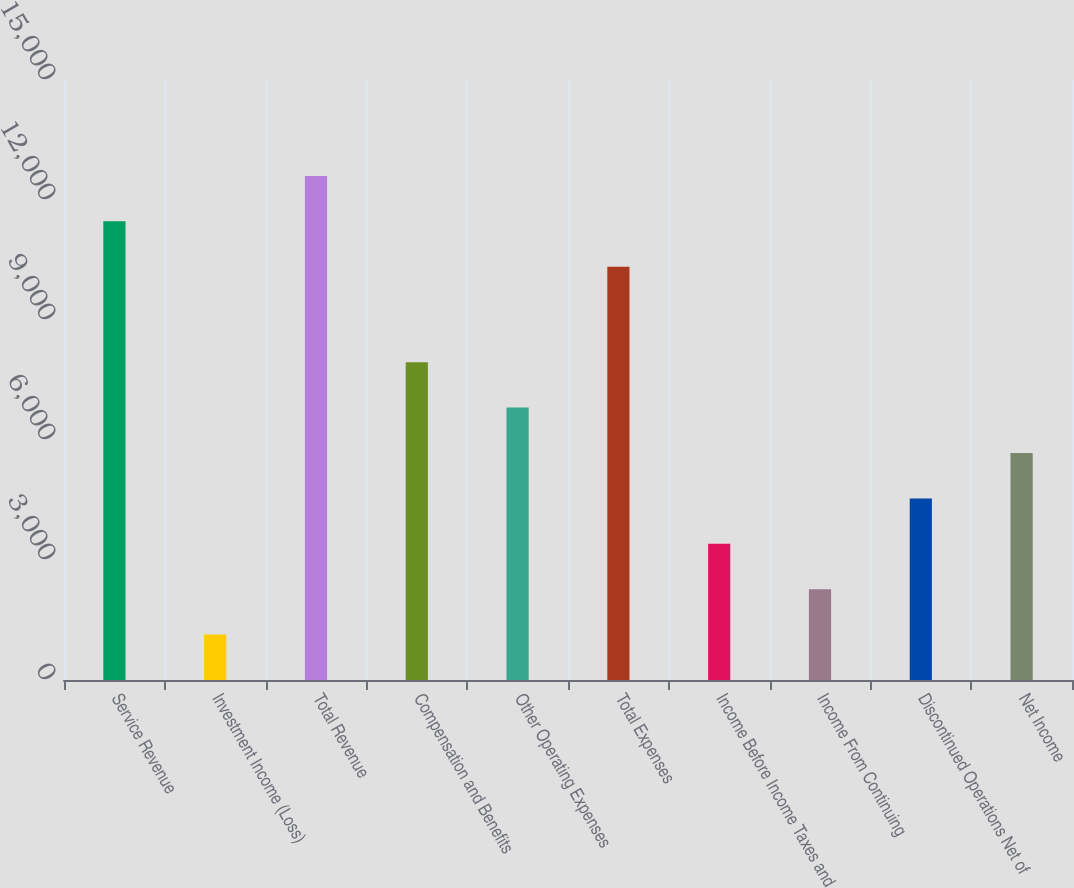Convert chart to OTSL. <chart><loc_0><loc_0><loc_500><loc_500><bar_chart><fcel>Service Revenue<fcel>Investment Income (Loss)<fcel>Total Revenue<fcel>Compensation and Benefits<fcel>Other Operating Expenses<fcel>Total Expenses<fcel>Income Before Income Taxes and<fcel>Income From Continuing<fcel>Discontinued Operations Net of<fcel>Net Income<nl><fcel>11465.9<fcel>1135.68<fcel>12600.8<fcel>7945.2<fcel>6810.28<fcel>10331<fcel>3405.52<fcel>2270.6<fcel>4540.44<fcel>5675.36<nl></chart> 